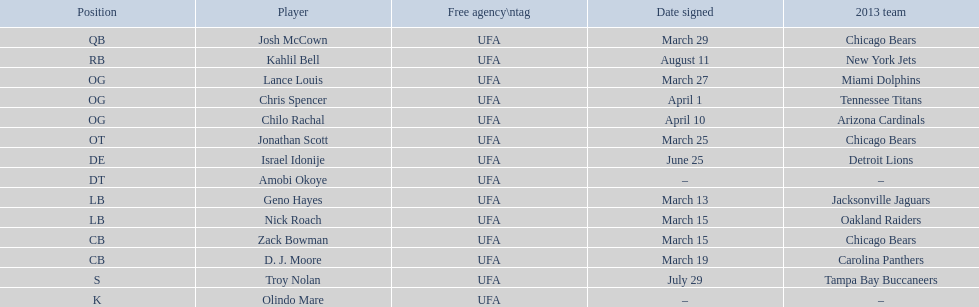Who are all the participants? Josh McCown, Kahlil Bell, Lance Louis, Chris Spencer, Chilo Rachal, Jonathan Scott, Israel Idonije, Amobi Okoye, Geno Hayes, Nick Roach, Zack Bowman, D. J. Moore, Troy Nolan, Olindo Mare. When did they join? March 29, August 11, March 27, April 1, April 10, March 25, June 25, –, March 13, March 15, March 15, March 19, July 29, –. In addition to nick roach, who was also signed on march 15? Zack Bowman. 